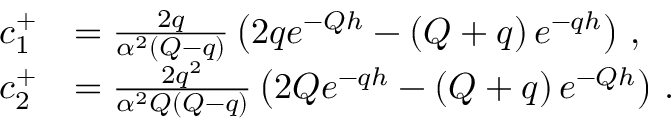Convert formula to latex. <formula><loc_0><loc_0><loc_500><loc_500>\begin{array} { r l } { c _ { 1 } ^ { + } } & { = \frac { 2 q } { \alpha ^ { 2 } \left ( Q - q \right ) } \left ( 2 q e ^ { - Q h } - \left ( Q + q \right ) e ^ { - q h } \right ) \, , } \\ { c _ { 2 } ^ { + } } & { = \frac { 2 q ^ { 2 } } { \alpha ^ { 2 } Q \left ( Q - q \right ) } \left ( 2 Q e ^ { - q h } - \left ( Q + q \right ) e ^ { - Q h } \right ) \, . } \end{array}</formula> 